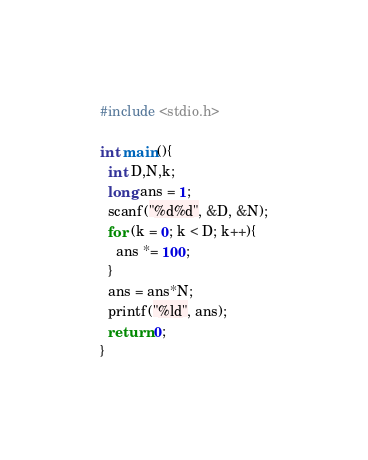<code> <loc_0><loc_0><loc_500><loc_500><_C_>#include <stdio.h>

int main(){
  int D,N,k;
  long ans = 1;
  scanf("%d%d", &D, &N);
  for (k = 0; k < D; k++){
    ans *= 100;
  }
  ans = ans*N;
  printf("%ld", ans);
  return 0;
}
</code> 